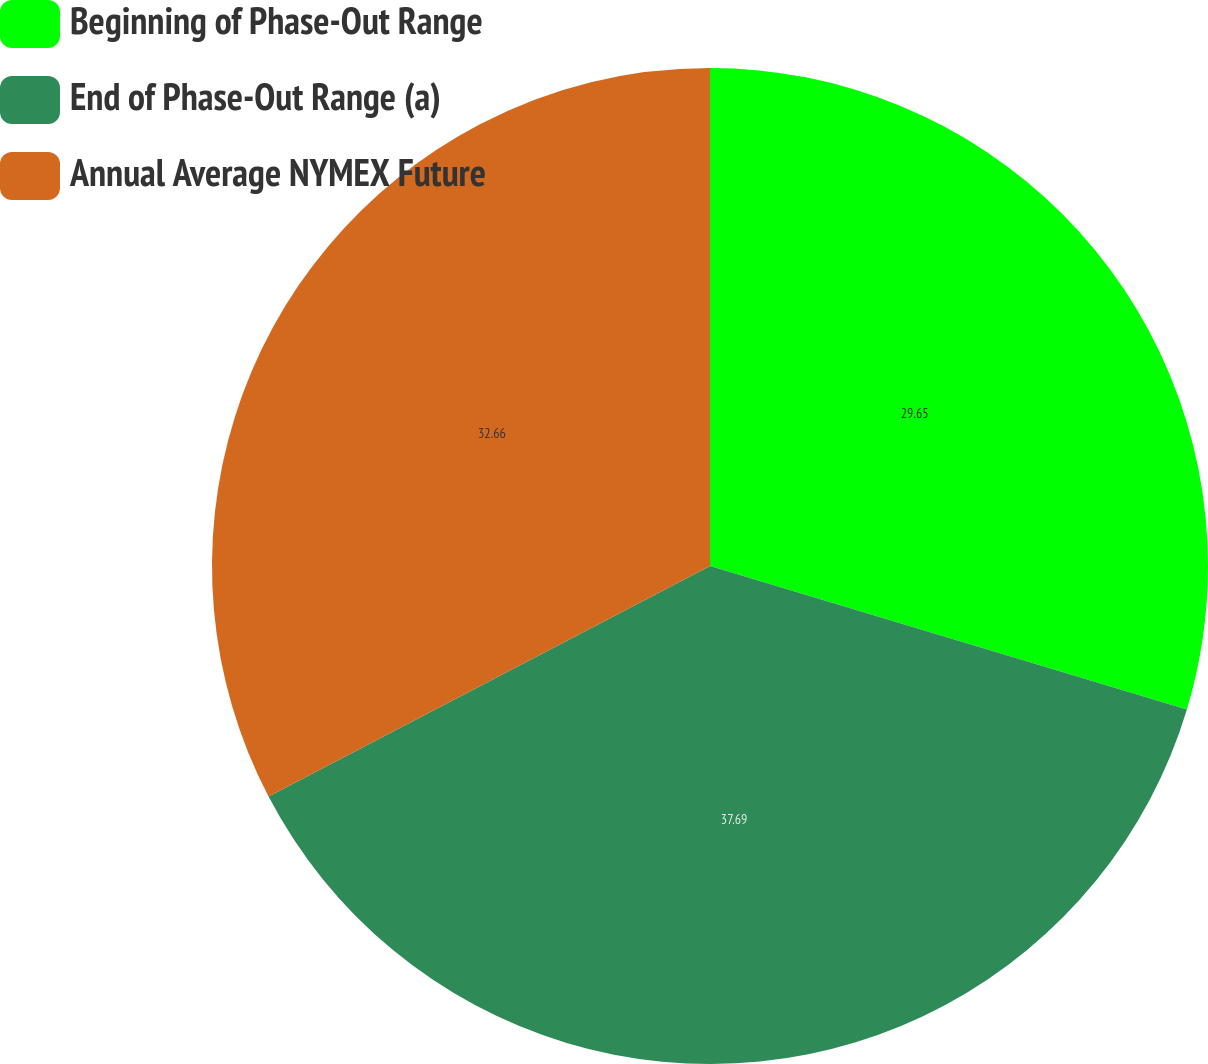Convert chart. <chart><loc_0><loc_0><loc_500><loc_500><pie_chart><fcel>Beginning of Phase-Out Range<fcel>End of Phase-Out Range (a)<fcel>Annual Average NYMEX Future<nl><fcel>29.65%<fcel>37.69%<fcel>32.66%<nl></chart> 